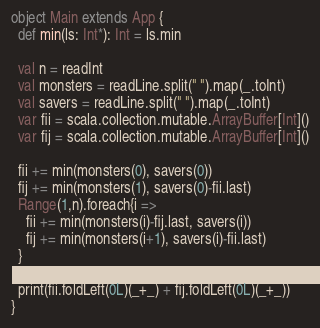Convert code to text. <code><loc_0><loc_0><loc_500><loc_500><_Scala_>object Main extends App {
  def min(ls: Int*): Int = ls.min
  
  val n = readInt
  val monsters = readLine.split(" ").map(_.toInt)
  val savers = readLine.split(" ").map(_.toInt)
  var fii = scala.collection.mutable.ArrayBuffer[Int]()
  var fij = scala.collection.mutable.ArrayBuffer[Int]()
  
  fii += min(monsters(0), savers(0))
  fij += min(monsters(1), savers(0)-fii.last)
  Range(1,n).foreach{i =>
    fii += min(monsters(i)-fij.last, savers(i))
    fij += min(monsters(i+1), savers(i)-fii.last)
  }
  
  print(fii.foldLeft(0L)(_+_) + fij.foldLeft(0L)(_+_))
}</code> 